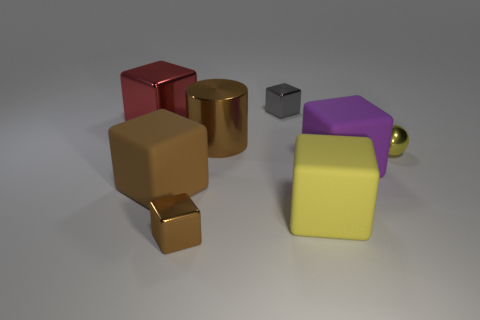There is a small cube in front of the red shiny block; is it the same color as the large rubber thing that is left of the large cylinder?
Give a very brief answer. Yes. Is the material of the thing behind the big red metallic block the same as the small cube that is in front of the big red block?
Ensure brevity in your answer.  Yes. How many purple spheres are the same size as the brown metallic block?
Your response must be concise. 0. Is the number of red cubes less than the number of tiny blue metal objects?
Provide a short and direct response. No. There is a brown object that is behind the big rubber object on the left side of the cylinder; what shape is it?
Your response must be concise. Cylinder. What shape is the brown metal thing that is the same size as the gray object?
Keep it short and to the point. Cube. Is there a large red metal thing of the same shape as the tiny brown shiny thing?
Offer a very short reply. Yes. What is the large red thing made of?
Your answer should be compact. Metal. Are there any small gray metal things on the left side of the small gray object?
Your response must be concise. No. What number of matte cubes are in front of the matte block that is left of the tiny gray block?
Provide a succinct answer. 1. 